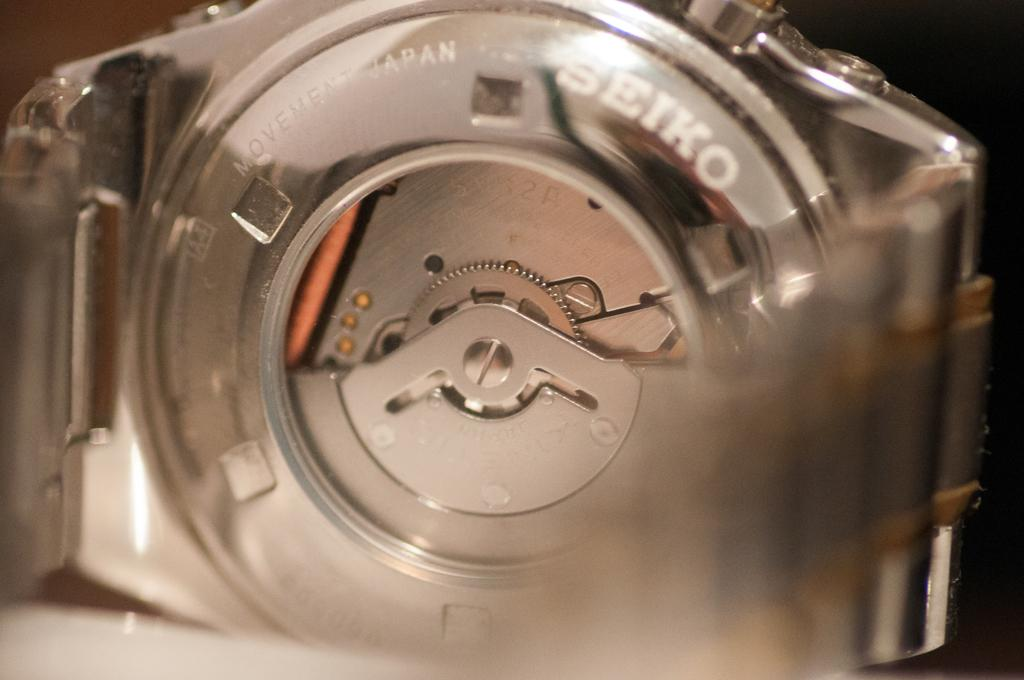<image>
Share a concise interpretation of the image provided. A mechanical device that says movement Japan and Seiko on it. 